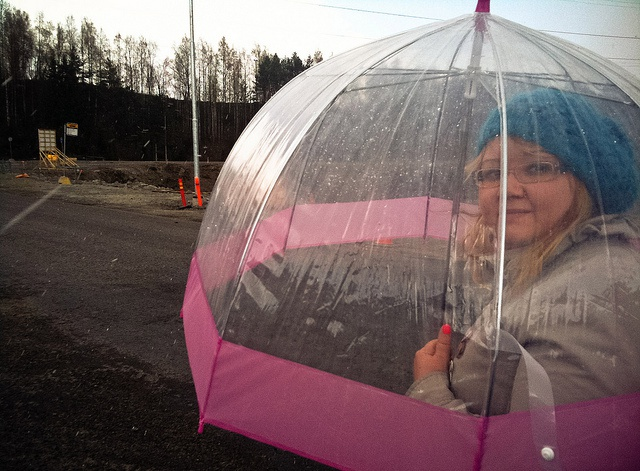Describe the objects in this image and their specific colors. I can see umbrella in beige, gray, brown, darkgray, and purple tones and people in beige, gray, blue, and darkgray tones in this image. 